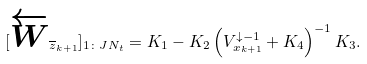Convert formula to latex. <formula><loc_0><loc_0><loc_500><loc_500>[ \overleftarrow { W } _ { \overline { z } _ { k + 1 } } ] _ { 1 \colon J N _ { t } } = K _ { 1 } - K _ { 2 } \left ( V _ { x _ { k + 1 } } ^ { \downarrow - 1 } + K _ { 4 } \right ) ^ { - 1 } K _ { 3 } .</formula> 